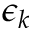<formula> <loc_0><loc_0><loc_500><loc_500>\epsilon _ { k }</formula> 